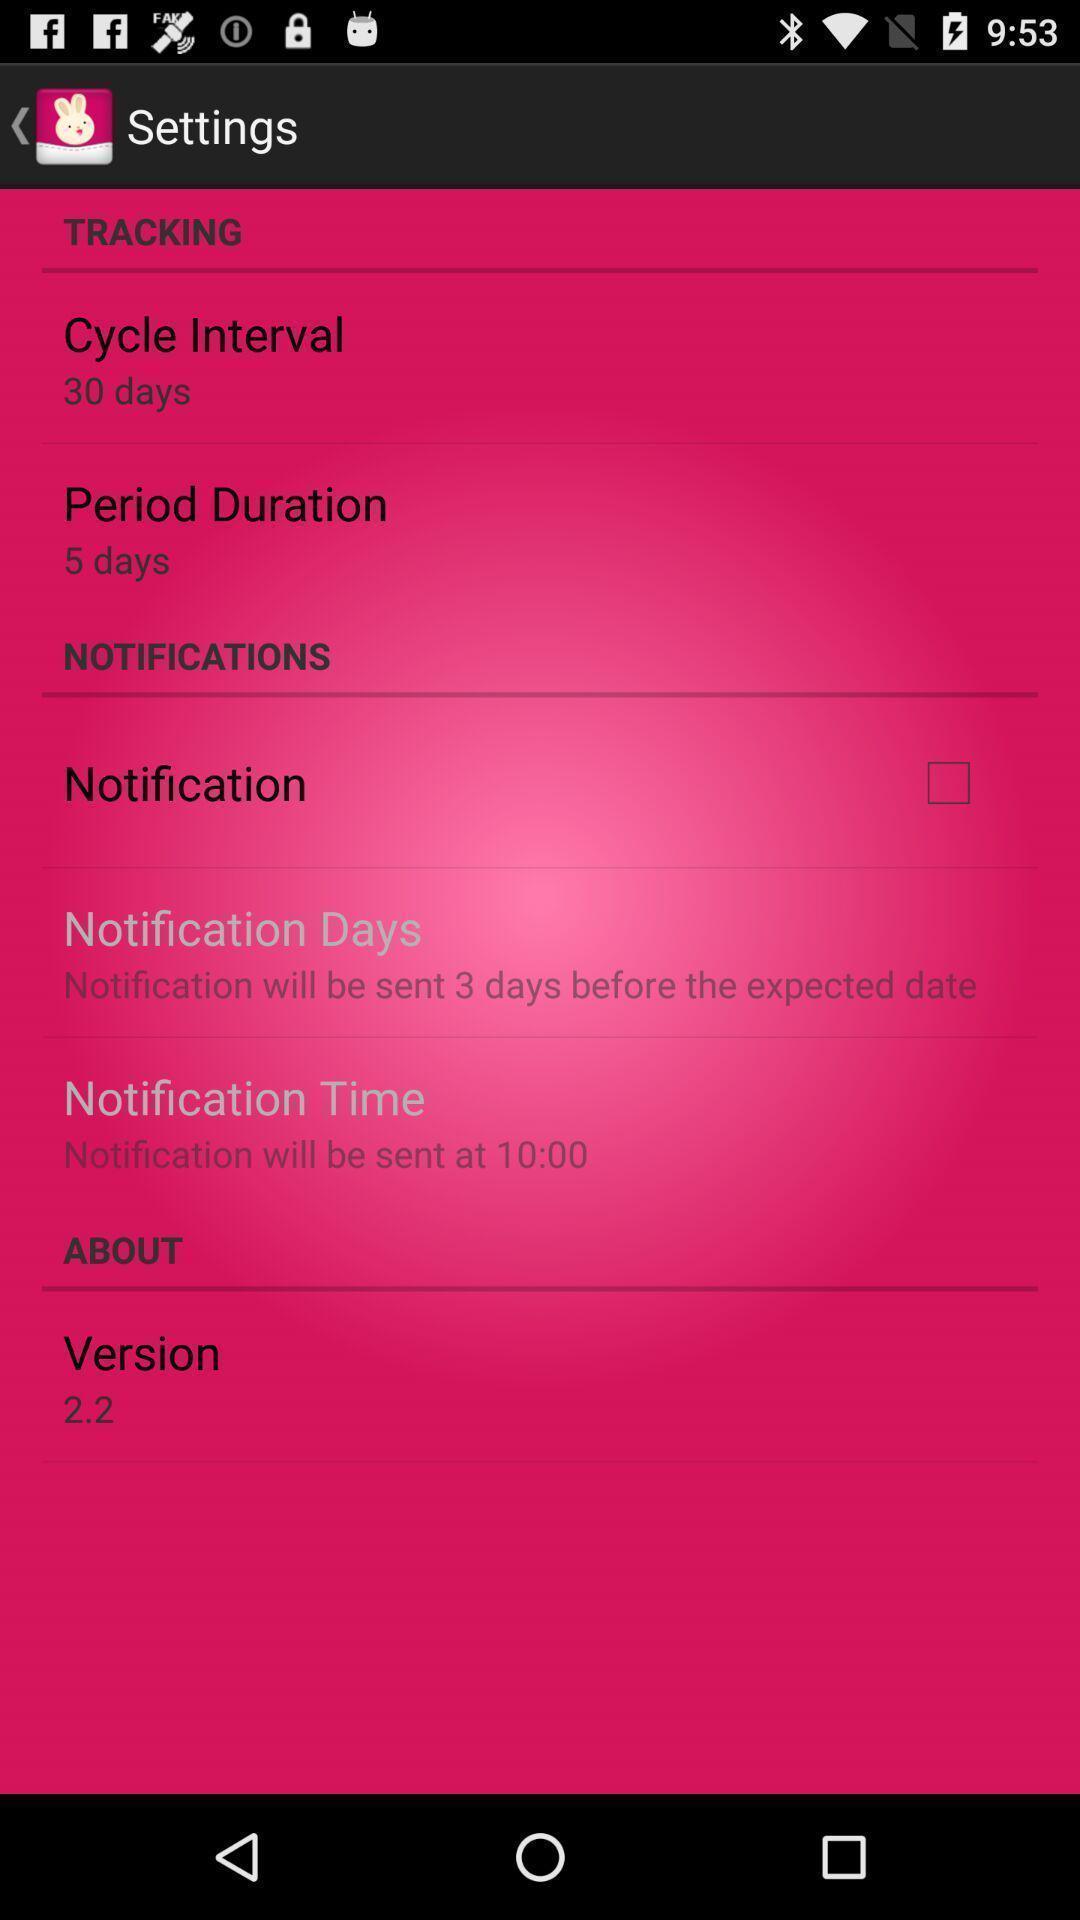Explain the elements present in this screenshot. Settings page. 